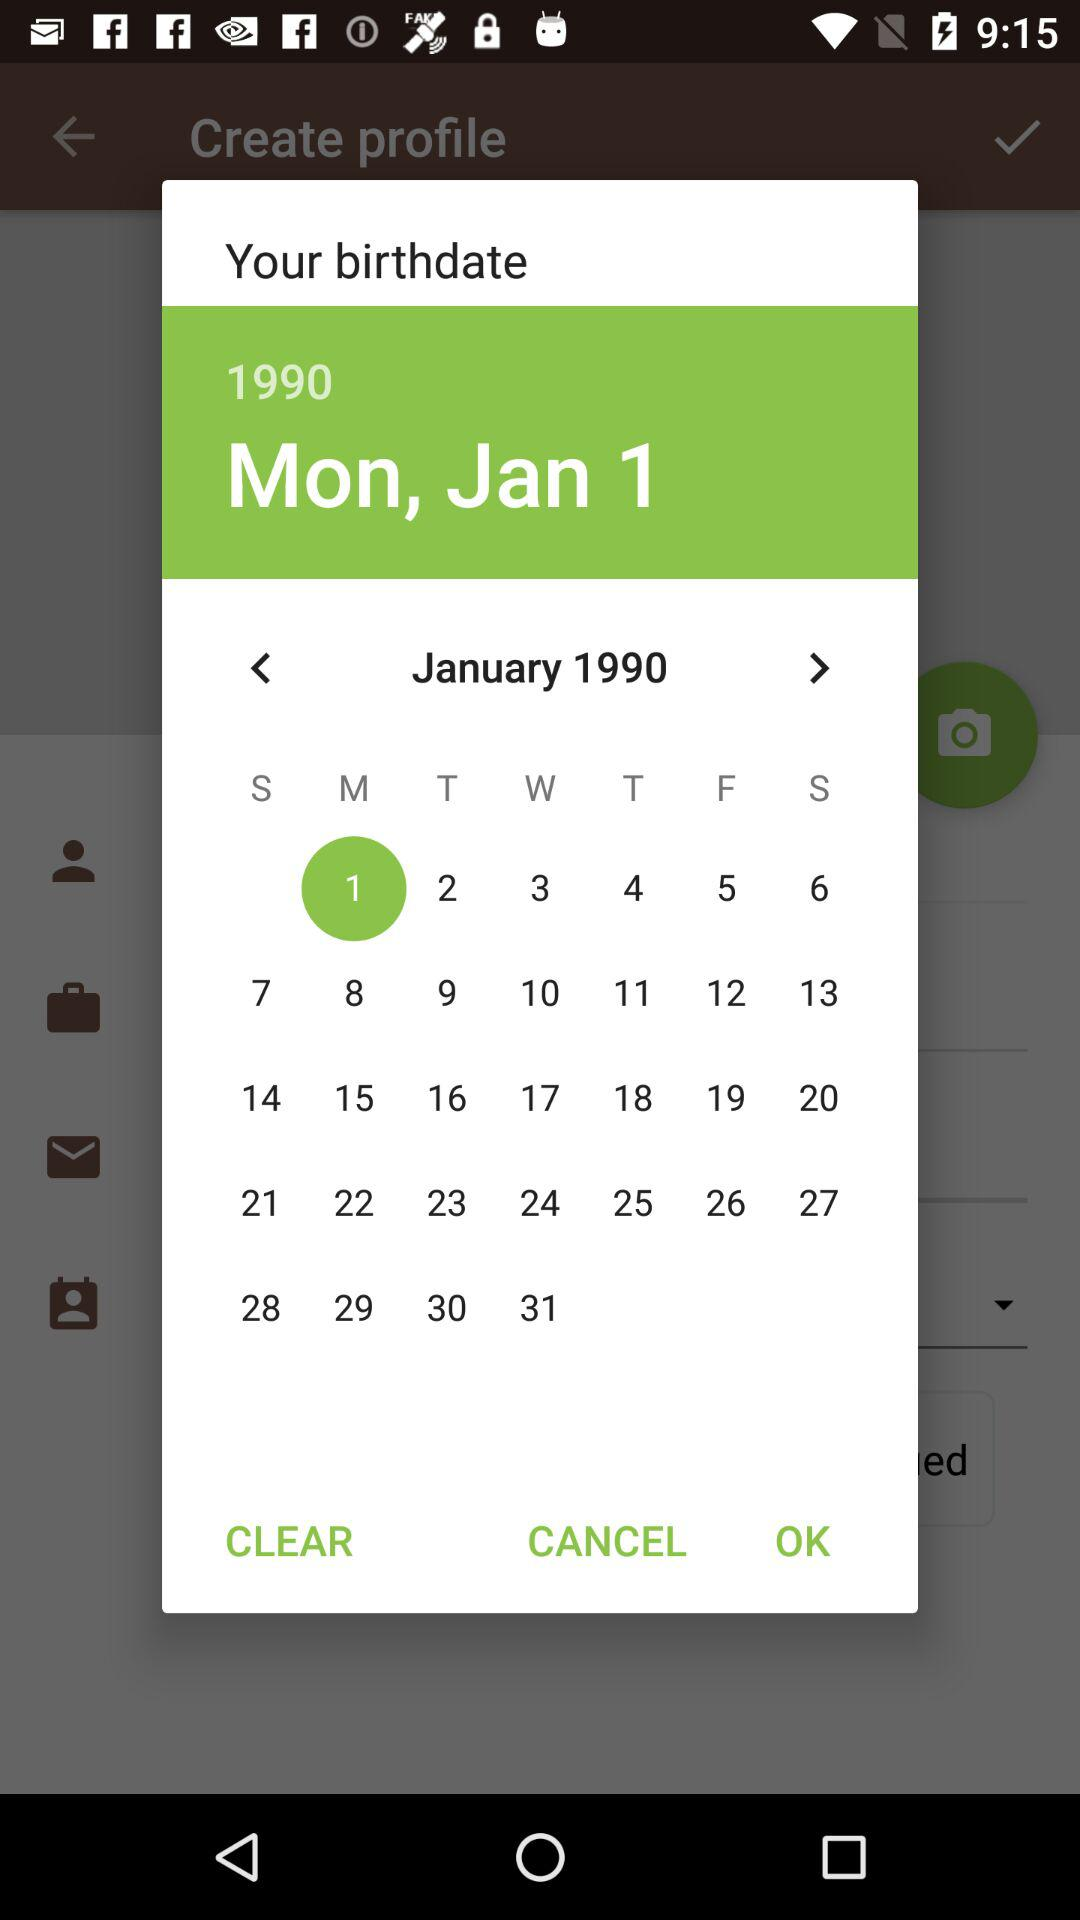What is the birthdate? The birthdate is Monday, January 1, 1990. 